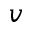<formula> <loc_0><loc_0><loc_500><loc_500>v</formula> 